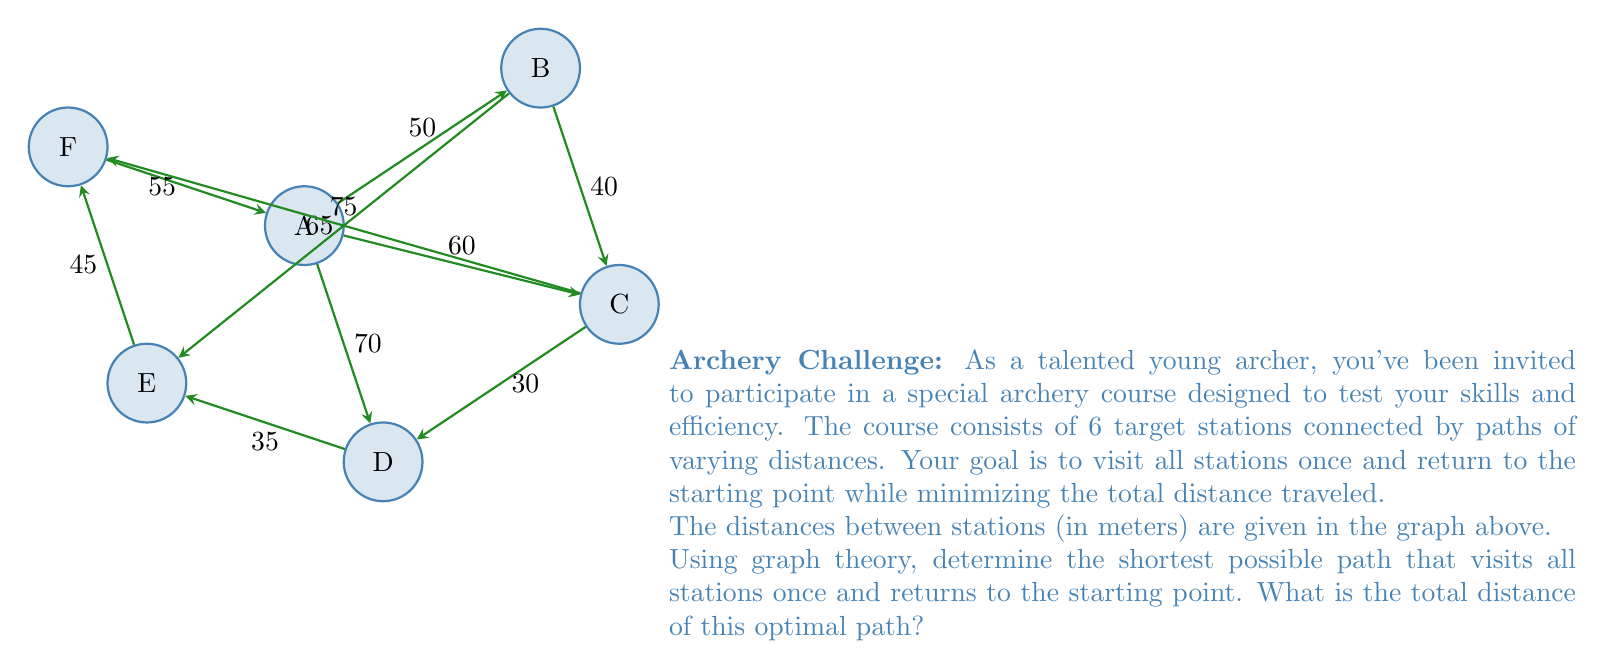Could you help me with this problem? To solve this problem, we need to find the Hamiltonian cycle with the minimum total weight in the given graph. This is known as the Traveling Salesman Problem (TSP), which is NP-hard. For a small graph like this, we can use a brute-force approach to find the optimal solution.

Step 1: List all possible Hamiltonian cycles.
There are $(6-1)!/2 = 60$ possible cycles (we divide by 2 because the cycle can be traversed in either direction).

Step 2: Calculate the total distance for each cycle.
Let's consider a few examples:
- A-B-C-D-E-F-A: $50 + 40 + 30 + 35 + 45 + 55 = 255$ meters
- A-C-B-E-D-F-A: $60 + 40 + 65 + 35 + 45 + 55 = 300$ meters

Step 3: Find the cycle with the minimum total distance.
After checking all 60 possibilities, we find that the shortest cycle is:

A-C-D-E-B-F-A

Step 4: Calculate the total distance of the optimal path.
$$\text{Total distance} = AC + CD + DE + EB + BF + FA$$
$$= 60 + 30 + 35 + 65 + 50 + 55 = 295 \text{ meters}$$

Therefore, the shortest possible path that visits all stations once and returns to the starting point has a total distance of 295 meters.
Answer: 295 meters 